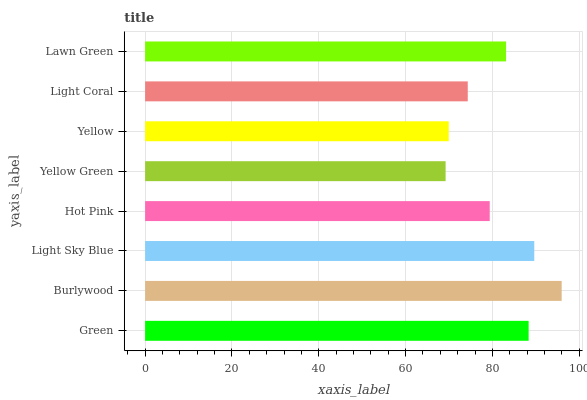Is Yellow Green the minimum?
Answer yes or no. Yes. Is Burlywood the maximum?
Answer yes or no. Yes. Is Light Sky Blue the minimum?
Answer yes or no. No. Is Light Sky Blue the maximum?
Answer yes or no. No. Is Burlywood greater than Light Sky Blue?
Answer yes or no. Yes. Is Light Sky Blue less than Burlywood?
Answer yes or no. Yes. Is Light Sky Blue greater than Burlywood?
Answer yes or no. No. Is Burlywood less than Light Sky Blue?
Answer yes or no. No. Is Lawn Green the high median?
Answer yes or no. Yes. Is Hot Pink the low median?
Answer yes or no. Yes. Is Green the high median?
Answer yes or no. No. Is Yellow the low median?
Answer yes or no. No. 